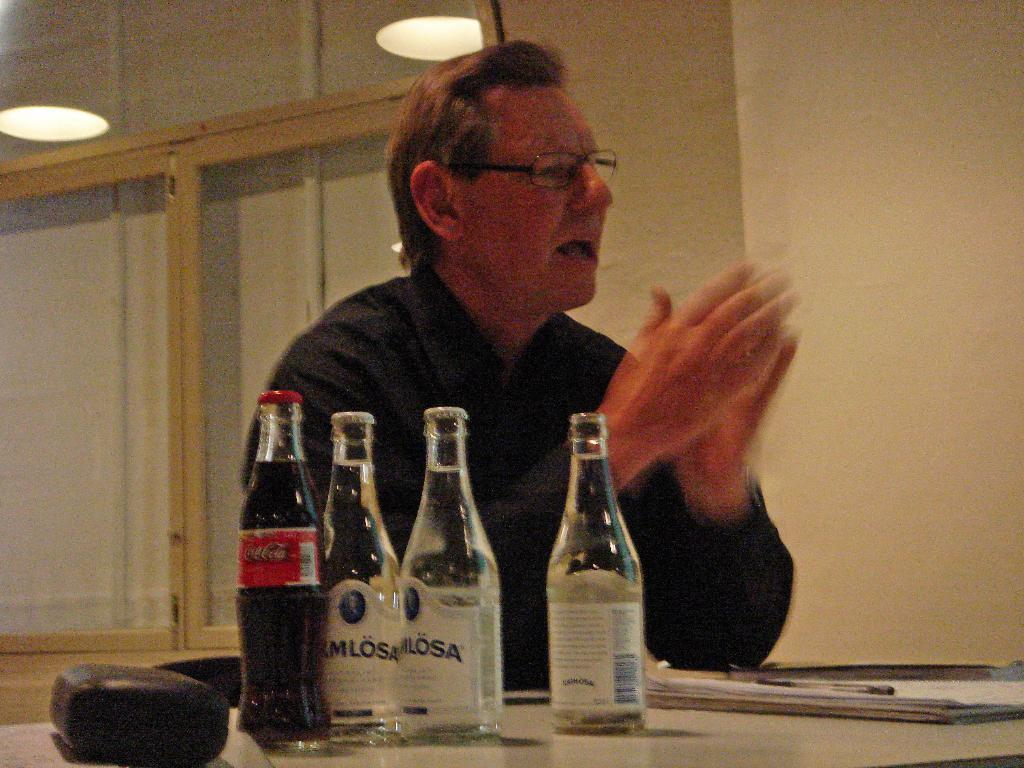What is the person in the image doing? The person is sitting on a chair at a table. How many bottles are on the table? There are 4 bottles on the table. What else is on the table besides the bottles? There is a book, a pen, and a box on the table. What can be seen in the background of the image? There is a wall, windows, and a reflection of light in the background. Can you describe the seashore in the image? There is no seashore present in the image; it features a person sitting at a table with various objects. What type of sun is shining through the windows in the image? There is no sun visible in the image; only a reflection of light can be seen in the background. 